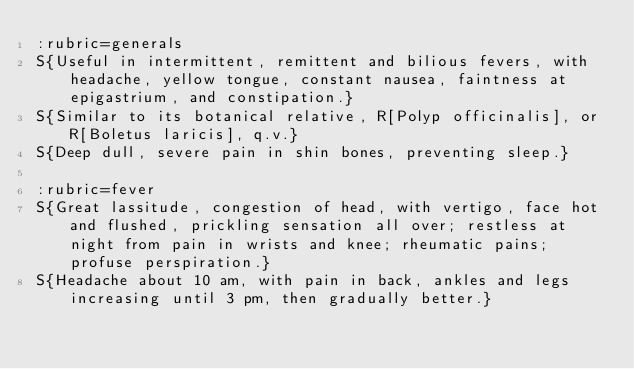<code> <loc_0><loc_0><loc_500><loc_500><_ObjectiveC_>:rubric=generals
S{Useful in intermittent, remittent and bilious fevers, with headache, yellow tongue, constant nausea, faintness at epigastrium, and constipation.}
S{Similar to its botanical relative, R[Polyp officinalis], or R[Boletus laricis], q.v.}
S{Deep dull, severe pain in shin bones, preventing sleep.}

:rubric=fever
S{Great lassitude, congestion of head, with vertigo, face hot and flushed, prickling sensation all over; restless at night from pain in wrists and knee; rheumatic pains; profuse perspiration.}
S{Headache about 10 am, with pain in back, ankles and legs increasing until 3 pm, then gradually better.}</code> 